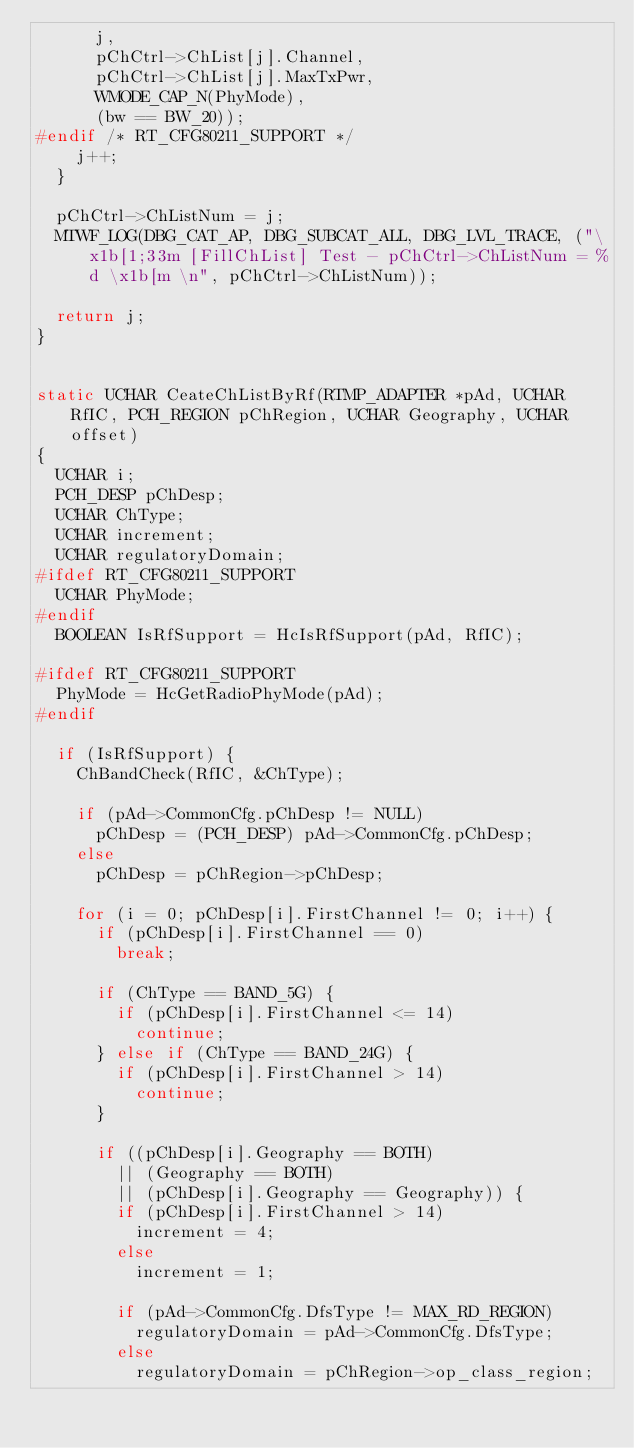Convert code to text. <code><loc_0><loc_0><loc_500><loc_500><_C_>			j,
			pChCtrl->ChList[j].Channel,
			pChCtrl->ChList[j].MaxTxPwr,
			WMODE_CAP_N(PhyMode),
			(bw == BW_20));
#endif /* RT_CFG80211_SUPPORT */
		j++;
	}

	pChCtrl->ChListNum = j;
	MTWF_LOG(DBG_CAT_AP, DBG_SUBCAT_ALL, DBG_LVL_TRACE, ("\x1b[1;33m [FillChList] Test - pChCtrl->ChListNum = %d \x1b[m \n", pChCtrl->ChListNum));

	return j;
}


static UCHAR CeateChListByRf(RTMP_ADAPTER *pAd, UCHAR RfIC, PCH_REGION pChRegion, UCHAR Geography, UCHAR offset)
{
	UCHAR i;
	PCH_DESP pChDesp;
	UCHAR ChType;
	UCHAR increment;
	UCHAR regulatoryDomain;
#ifdef RT_CFG80211_SUPPORT
	UCHAR PhyMode;
#endif
	BOOLEAN IsRfSupport = HcIsRfSupport(pAd, RfIC);

#ifdef RT_CFG80211_SUPPORT
	PhyMode = HcGetRadioPhyMode(pAd);
#endif

	if (IsRfSupport) {
		ChBandCheck(RfIC, &ChType);

		if (pAd->CommonCfg.pChDesp != NULL)
			pChDesp = (PCH_DESP) pAd->CommonCfg.pChDesp;
		else
			pChDesp = pChRegion->pChDesp;

		for (i = 0; pChDesp[i].FirstChannel != 0; i++) {
			if (pChDesp[i].FirstChannel == 0)
				break;

			if (ChType == BAND_5G) {
				if (pChDesp[i].FirstChannel <= 14)
					continue;
			} else if (ChType == BAND_24G) {
				if (pChDesp[i].FirstChannel > 14)
					continue;
			}

			if ((pChDesp[i].Geography == BOTH)
				|| (Geography == BOTH)
				|| (pChDesp[i].Geography == Geography)) {
				if (pChDesp[i].FirstChannel > 14)
					increment = 4;
				else
					increment = 1;

				if (pAd->CommonCfg.DfsType != MAX_RD_REGION)
					regulatoryDomain = pAd->CommonCfg.DfsType;
				else
					regulatoryDomain = pChRegion->op_class_region;
</code> 